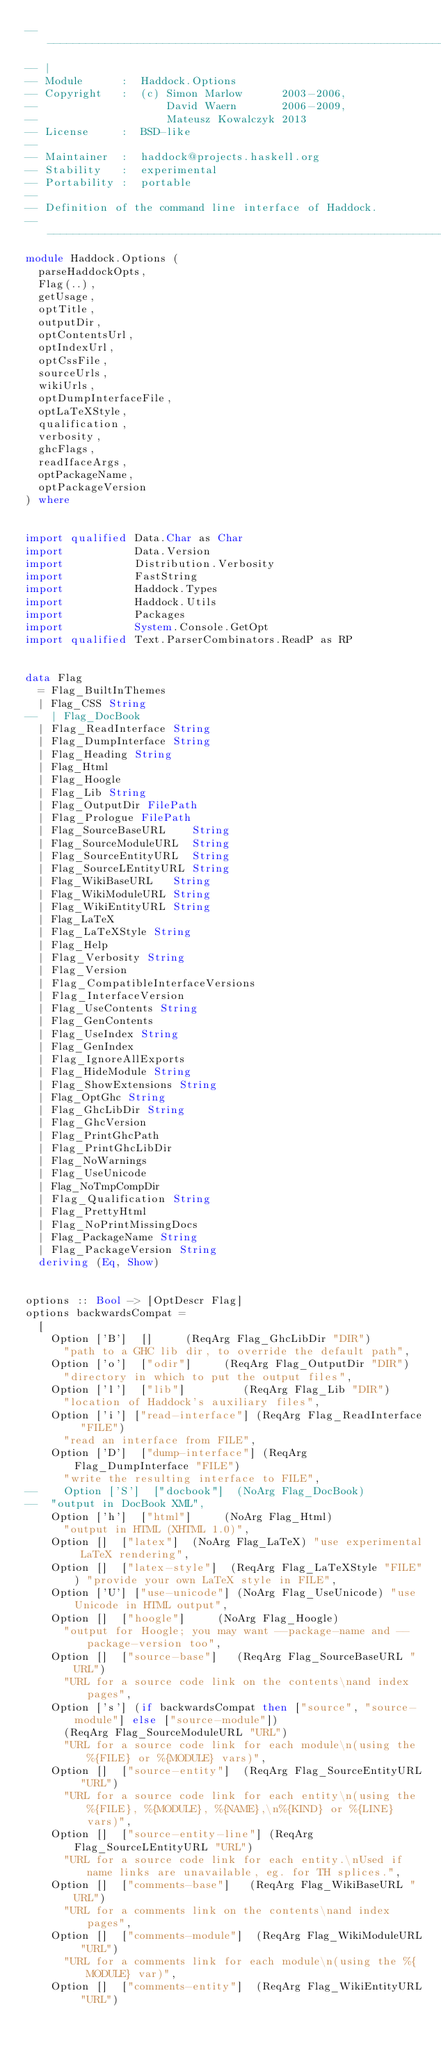<code> <loc_0><loc_0><loc_500><loc_500><_Haskell_>-----------------------------------------------------------------------------
-- |
-- Module      :  Haddock.Options
-- Copyright   :  (c) Simon Marlow      2003-2006,
--                    David Waern       2006-2009,
--                    Mateusz Kowalczyk 2013
-- License     :  BSD-like
--
-- Maintainer  :  haddock@projects.haskell.org
-- Stability   :  experimental
-- Portability :  portable
--
-- Definition of the command line interface of Haddock.
-----------------------------------------------------------------------------
module Haddock.Options (
  parseHaddockOpts,
  Flag(..),
  getUsage,
  optTitle,
  outputDir,
  optContentsUrl,
  optIndexUrl,
  optCssFile,
  sourceUrls,
  wikiUrls,
  optDumpInterfaceFile,
  optLaTeXStyle,
  qualification,
  verbosity,
  ghcFlags,
  readIfaceArgs,
  optPackageName,
  optPackageVersion
) where


import qualified Data.Char as Char
import           Data.Version
import           Distribution.Verbosity
import           FastString
import           Haddock.Types
import           Haddock.Utils
import           Packages
import           System.Console.GetOpt
import qualified Text.ParserCombinators.ReadP as RP


data Flag
  = Flag_BuiltInThemes
  | Flag_CSS String
--  | Flag_DocBook
  | Flag_ReadInterface String
  | Flag_DumpInterface String
  | Flag_Heading String
  | Flag_Html
  | Flag_Hoogle
  | Flag_Lib String
  | Flag_OutputDir FilePath
  | Flag_Prologue FilePath
  | Flag_SourceBaseURL    String
  | Flag_SourceModuleURL  String
  | Flag_SourceEntityURL  String
  | Flag_SourceLEntityURL String
  | Flag_WikiBaseURL   String
  | Flag_WikiModuleURL String
  | Flag_WikiEntityURL String
  | Flag_LaTeX
  | Flag_LaTeXStyle String
  | Flag_Help
  | Flag_Verbosity String
  | Flag_Version
  | Flag_CompatibleInterfaceVersions
  | Flag_InterfaceVersion
  | Flag_UseContents String
  | Flag_GenContents
  | Flag_UseIndex String
  | Flag_GenIndex
  | Flag_IgnoreAllExports
  | Flag_HideModule String
  | Flag_ShowExtensions String
  | Flag_OptGhc String
  | Flag_GhcLibDir String
  | Flag_GhcVersion
  | Flag_PrintGhcPath
  | Flag_PrintGhcLibDir
  | Flag_NoWarnings
  | Flag_UseUnicode
  | Flag_NoTmpCompDir
  | Flag_Qualification String
  | Flag_PrettyHtml
  | Flag_NoPrintMissingDocs
  | Flag_PackageName String
  | Flag_PackageVersion String
  deriving (Eq, Show)


options :: Bool -> [OptDescr Flag]
options backwardsCompat =
  [
    Option ['B']  []     (ReqArg Flag_GhcLibDir "DIR")
      "path to a GHC lib dir, to override the default path",
    Option ['o']  ["odir"]     (ReqArg Flag_OutputDir "DIR")
      "directory in which to put the output files",
    Option ['l']  ["lib"]         (ReqArg Flag_Lib "DIR")
      "location of Haddock's auxiliary files",
    Option ['i'] ["read-interface"] (ReqArg Flag_ReadInterface "FILE")
      "read an interface from FILE",
    Option ['D']  ["dump-interface"] (ReqArg Flag_DumpInterface "FILE")
      "write the resulting interface to FILE",
--    Option ['S']  ["docbook"]  (NoArg Flag_DocBook)
--  "output in DocBook XML",
    Option ['h']  ["html"]     (NoArg Flag_Html)
      "output in HTML (XHTML 1.0)",
    Option []  ["latex"]  (NoArg Flag_LaTeX) "use experimental LaTeX rendering",
    Option []  ["latex-style"]  (ReqArg Flag_LaTeXStyle "FILE") "provide your own LaTeX style in FILE",
    Option ['U'] ["use-unicode"] (NoArg Flag_UseUnicode) "use Unicode in HTML output",
    Option []  ["hoogle"]     (NoArg Flag_Hoogle)
      "output for Hoogle; you may want --package-name and --package-version too",
    Option []  ["source-base"]   (ReqArg Flag_SourceBaseURL "URL")
      "URL for a source code link on the contents\nand index pages",
    Option ['s'] (if backwardsCompat then ["source", "source-module"] else ["source-module"])
      (ReqArg Flag_SourceModuleURL "URL")
      "URL for a source code link for each module\n(using the %{FILE} or %{MODULE} vars)",
    Option []  ["source-entity"]  (ReqArg Flag_SourceEntityURL "URL")
      "URL for a source code link for each entity\n(using the %{FILE}, %{MODULE}, %{NAME},\n%{KIND} or %{LINE} vars)",
    Option []  ["source-entity-line"] (ReqArg Flag_SourceLEntityURL "URL")
      "URL for a source code link for each entity.\nUsed if name links are unavailable, eg. for TH splices.",
    Option []  ["comments-base"]   (ReqArg Flag_WikiBaseURL "URL")
      "URL for a comments link on the contents\nand index pages",
    Option []  ["comments-module"]  (ReqArg Flag_WikiModuleURL "URL")
      "URL for a comments link for each module\n(using the %{MODULE} var)",
    Option []  ["comments-entity"]  (ReqArg Flag_WikiEntityURL "URL")</code> 